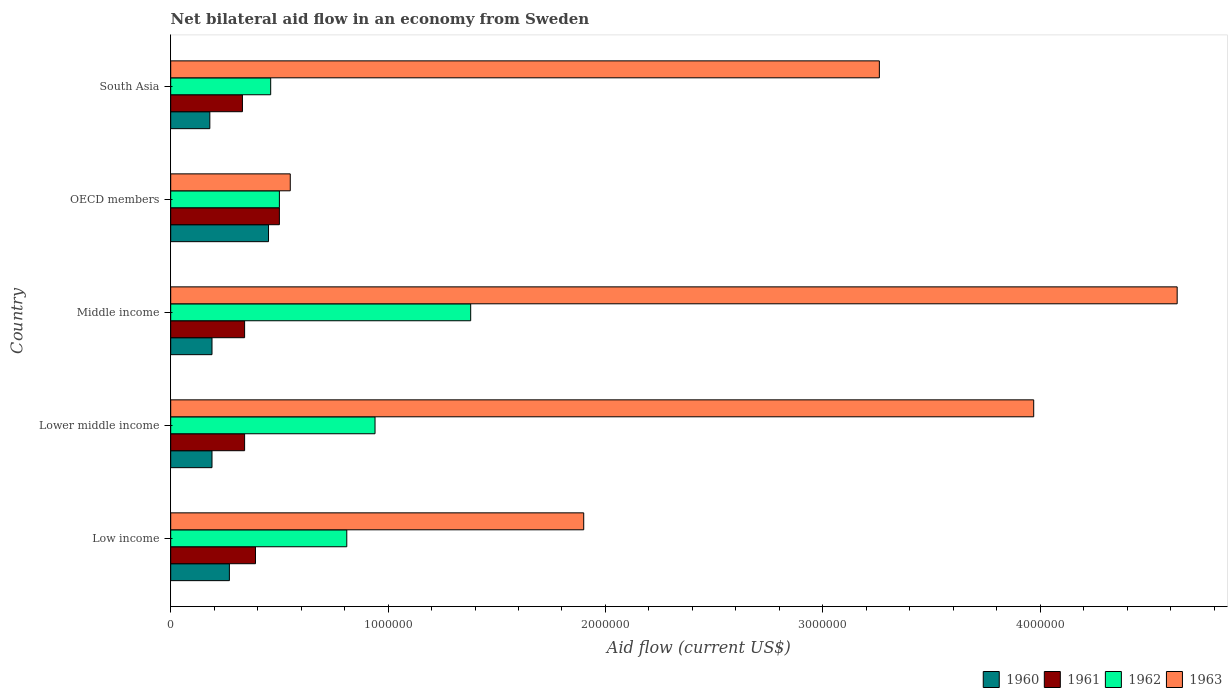How many different coloured bars are there?
Make the answer very short. 4. How many bars are there on the 2nd tick from the top?
Ensure brevity in your answer.  4. What is the label of the 2nd group of bars from the top?
Make the answer very short. OECD members. Across all countries, what is the maximum net bilateral aid flow in 1962?
Your answer should be very brief. 1.38e+06. Across all countries, what is the minimum net bilateral aid flow in 1960?
Give a very brief answer. 1.80e+05. In which country was the net bilateral aid flow in 1963 minimum?
Offer a very short reply. OECD members. What is the total net bilateral aid flow in 1963 in the graph?
Your response must be concise. 1.43e+07. What is the difference between the net bilateral aid flow in 1963 in Low income and that in Lower middle income?
Offer a terse response. -2.07e+06. What is the difference between the net bilateral aid flow in 1961 in OECD members and the net bilateral aid flow in 1962 in Lower middle income?
Your answer should be very brief. -4.40e+05. What is the average net bilateral aid flow in 1963 per country?
Give a very brief answer. 2.86e+06. What is the difference between the net bilateral aid flow in 1960 and net bilateral aid flow in 1963 in South Asia?
Your answer should be compact. -3.08e+06. What is the ratio of the net bilateral aid flow in 1962 in Lower middle income to that in Middle income?
Offer a very short reply. 0.68. Is the net bilateral aid flow in 1963 in Middle income less than that in South Asia?
Ensure brevity in your answer.  No. What is the difference between the highest and the second highest net bilateral aid flow in 1961?
Give a very brief answer. 1.10e+05. What is the difference between the highest and the lowest net bilateral aid flow in 1962?
Your response must be concise. 9.20e+05. Is it the case that in every country, the sum of the net bilateral aid flow in 1961 and net bilateral aid flow in 1962 is greater than the sum of net bilateral aid flow in 1963 and net bilateral aid flow in 1960?
Offer a terse response. No. What does the 4th bar from the top in OECD members represents?
Provide a short and direct response. 1960. Is it the case that in every country, the sum of the net bilateral aid flow in 1962 and net bilateral aid flow in 1960 is greater than the net bilateral aid flow in 1963?
Your answer should be very brief. No. How many countries are there in the graph?
Give a very brief answer. 5. Where does the legend appear in the graph?
Make the answer very short. Bottom right. What is the title of the graph?
Give a very brief answer. Net bilateral aid flow in an economy from Sweden. Does "1993" appear as one of the legend labels in the graph?
Your answer should be very brief. No. What is the label or title of the X-axis?
Offer a very short reply. Aid flow (current US$). What is the Aid flow (current US$) in 1960 in Low income?
Provide a short and direct response. 2.70e+05. What is the Aid flow (current US$) in 1962 in Low income?
Keep it short and to the point. 8.10e+05. What is the Aid flow (current US$) of 1963 in Low income?
Keep it short and to the point. 1.90e+06. What is the Aid flow (current US$) of 1961 in Lower middle income?
Your answer should be very brief. 3.40e+05. What is the Aid flow (current US$) in 1962 in Lower middle income?
Make the answer very short. 9.40e+05. What is the Aid flow (current US$) of 1963 in Lower middle income?
Offer a very short reply. 3.97e+06. What is the Aid flow (current US$) in 1960 in Middle income?
Your response must be concise. 1.90e+05. What is the Aid flow (current US$) of 1961 in Middle income?
Ensure brevity in your answer.  3.40e+05. What is the Aid flow (current US$) of 1962 in Middle income?
Make the answer very short. 1.38e+06. What is the Aid flow (current US$) of 1963 in Middle income?
Your response must be concise. 4.63e+06. What is the Aid flow (current US$) of 1960 in OECD members?
Your response must be concise. 4.50e+05. What is the Aid flow (current US$) of 1961 in OECD members?
Offer a very short reply. 5.00e+05. What is the Aid flow (current US$) of 1962 in South Asia?
Your response must be concise. 4.60e+05. What is the Aid flow (current US$) in 1963 in South Asia?
Make the answer very short. 3.26e+06. Across all countries, what is the maximum Aid flow (current US$) in 1961?
Give a very brief answer. 5.00e+05. Across all countries, what is the maximum Aid flow (current US$) of 1962?
Ensure brevity in your answer.  1.38e+06. Across all countries, what is the maximum Aid flow (current US$) in 1963?
Your answer should be very brief. 4.63e+06. Across all countries, what is the minimum Aid flow (current US$) of 1960?
Your response must be concise. 1.80e+05. Across all countries, what is the minimum Aid flow (current US$) in 1962?
Give a very brief answer. 4.60e+05. What is the total Aid flow (current US$) of 1960 in the graph?
Your answer should be very brief. 1.28e+06. What is the total Aid flow (current US$) in 1961 in the graph?
Your answer should be very brief. 1.90e+06. What is the total Aid flow (current US$) of 1962 in the graph?
Make the answer very short. 4.09e+06. What is the total Aid flow (current US$) in 1963 in the graph?
Offer a very short reply. 1.43e+07. What is the difference between the Aid flow (current US$) in 1961 in Low income and that in Lower middle income?
Your answer should be compact. 5.00e+04. What is the difference between the Aid flow (current US$) of 1962 in Low income and that in Lower middle income?
Give a very brief answer. -1.30e+05. What is the difference between the Aid flow (current US$) of 1963 in Low income and that in Lower middle income?
Your answer should be very brief. -2.07e+06. What is the difference between the Aid flow (current US$) of 1962 in Low income and that in Middle income?
Make the answer very short. -5.70e+05. What is the difference between the Aid flow (current US$) in 1963 in Low income and that in Middle income?
Your answer should be compact. -2.73e+06. What is the difference between the Aid flow (current US$) of 1961 in Low income and that in OECD members?
Provide a succinct answer. -1.10e+05. What is the difference between the Aid flow (current US$) in 1962 in Low income and that in OECD members?
Your answer should be compact. 3.10e+05. What is the difference between the Aid flow (current US$) of 1963 in Low income and that in OECD members?
Ensure brevity in your answer.  1.35e+06. What is the difference between the Aid flow (current US$) in 1961 in Low income and that in South Asia?
Keep it short and to the point. 6.00e+04. What is the difference between the Aid flow (current US$) in 1963 in Low income and that in South Asia?
Give a very brief answer. -1.36e+06. What is the difference between the Aid flow (current US$) of 1960 in Lower middle income and that in Middle income?
Offer a very short reply. 0. What is the difference between the Aid flow (current US$) of 1961 in Lower middle income and that in Middle income?
Your answer should be very brief. 0. What is the difference between the Aid flow (current US$) of 1962 in Lower middle income and that in Middle income?
Ensure brevity in your answer.  -4.40e+05. What is the difference between the Aid flow (current US$) of 1963 in Lower middle income and that in Middle income?
Offer a very short reply. -6.60e+05. What is the difference between the Aid flow (current US$) of 1960 in Lower middle income and that in OECD members?
Ensure brevity in your answer.  -2.60e+05. What is the difference between the Aid flow (current US$) of 1961 in Lower middle income and that in OECD members?
Provide a succinct answer. -1.60e+05. What is the difference between the Aid flow (current US$) in 1962 in Lower middle income and that in OECD members?
Offer a very short reply. 4.40e+05. What is the difference between the Aid flow (current US$) of 1963 in Lower middle income and that in OECD members?
Your response must be concise. 3.42e+06. What is the difference between the Aid flow (current US$) in 1961 in Lower middle income and that in South Asia?
Make the answer very short. 10000. What is the difference between the Aid flow (current US$) in 1963 in Lower middle income and that in South Asia?
Your answer should be compact. 7.10e+05. What is the difference between the Aid flow (current US$) in 1961 in Middle income and that in OECD members?
Provide a short and direct response. -1.60e+05. What is the difference between the Aid flow (current US$) of 1962 in Middle income and that in OECD members?
Make the answer very short. 8.80e+05. What is the difference between the Aid flow (current US$) in 1963 in Middle income and that in OECD members?
Provide a short and direct response. 4.08e+06. What is the difference between the Aid flow (current US$) in 1962 in Middle income and that in South Asia?
Your response must be concise. 9.20e+05. What is the difference between the Aid flow (current US$) of 1963 in Middle income and that in South Asia?
Your answer should be compact. 1.37e+06. What is the difference between the Aid flow (current US$) in 1963 in OECD members and that in South Asia?
Give a very brief answer. -2.71e+06. What is the difference between the Aid flow (current US$) of 1960 in Low income and the Aid flow (current US$) of 1962 in Lower middle income?
Your response must be concise. -6.70e+05. What is the difference between the Aid flow (current US$) of 1960 in Low income and the Aid flow (current US$) of 1963 in Lower middle income?
Offer a terse response. -3.70e+06. What is the difference between the Aid flow (current US$) of 1961 in Low income and the Aid flow (current US$) of 1962 in Lower middle income?
Your answer should be compact. -5.50e+05. What is the difference between the Aid flow (current US$) of 1961 in Low income and the Aid flow (current US$) of 1963 in Lower middle income?
Your response must be concise. -3.58e+06. What is the difference between the Aid flow (current US$) in 1962 in Low income and the Aid flow (current US$) in 1963 in Lower middle income?
Keep it short and to the point. -3.16e+06. What is the difference between the Aid flow (current US$) in 1960 in Low income and the Aid flow (current US$) in 1962 in Middle income?
Make the answer very short. -1.11e+06. What is the difference between the Aid flow (current US$) of 1960 in Low income and the Aid flow (current US$) of 1963 in Middle income?
Keep it short and to the point. -4.36e+06. What is the difference between the Aid flow (current US$) of 1961 in Low income and the Aid flow (current US$) of 1962 in Middle income?
Give a very brief answer. -9.90e+05. What is the difference between the Aid flow (current US$) of 1961 in Low income and the Aid flow (current US$) of 1963 in Middle income?
Keep it short and to the point. -4.24e+06. What is the difference between the Aid flow (current US$) of 1962 in Low income and the Aid flow (current US$) of 1963 in Middle income?
Your answer should be compact. -3.82e+06. What is the difference between the Aid flow (current US$) of 1960 in Low income and the Aid flow (current US$) of 1963 in OECD members?
Your answer should be compact. -2.80e+05. What is the difference between the Aid flow (current US$) in 1961 in Low income and the Aid flow (current US$) in 1962 in OECD members?
Your answer should be compact. -1.10e+05. What is the difference between the Aid flow (current US$) in 1960 in Low income and the Aid flow (current US$) in 1961 in South Asia?
Your answer should be compact. -6.00e+04. What is the difference between the Aid flow (current US$) in 1960 in Low income and the Aid flow (current US$) in 1963 in South Asia?
Your answer should be very brief. -2.99e+06. What is the difference between the Aid flow (current US$) in 1961 in Low income and the Aid flow (current US$) in 1962 in South Asia?
Provide a succinct answer. -7.00e+04. What is the difference between the Aid flow (current US$) of 1961 in Low income and the Aid flow (current US$) of 1963 in South Asia?
Give a very brief answer. -2.87e+06. What is the difference between the Aid flow (current US$) of 1962 in Low income and the Aid flow (current US$) of 1963 in South Asia?
Offer a terse response. -2.45e+06. What is the difference between the Aid flow (current US$) of 1960 in Lower middle income and the Aid flow (current US$) of 1961 in Middle income?
Offer a terse response. -1.50e+05. What is the difference between the Aid flow (current US$) in 1960 in Lower middle income and the Aid flow (current US$) in 1962 in Middle income?
Ensure brevity in your answer.  -1.19e+06. What is the difference between the Aid flow (current US$) in 1960 in Lower middle income and the Aid flow (current US$) in 1963 in Middle income?
Keep it short and to the point. -4.44e+06. What is the difference between the Aid flow (current US$) in 1961 in Lower middle income and the Aid flow (current US$) in 1962 in Middle income?
Offer a terse response. -1.04e+06. What is the difference between the Aid flow (current US$) in 1961 in Lower middle income and the Aid flow (current US$) in 1963 in Middle income?
Offer a very short reply. -4.29e+06. What is the difference between the Aid flow (current US$) in 1962 in Lower middle income and the Aid flow (current US$) in 1963 in Middle income?
Your answer should be very brief. -3.69e+06. What is the difference between the Aid flow (current US$) of 1960 in Lower middle income and the Aid flow (current US$) of 1961 in OECD members?
Provide a short and direct response. -3.10e+05. What is the difference between the Aid flow (current US$) of 1960 in Lower middle income and the Aid flow (current US$) of 1962 in OECD members?
Keep it short and to the point. -3.10e+05. What is the difference between the Aid flow (current US$) in 1960 in Lower middle income and the Aid flow (current US$) in 1963 in OECD members?
Make the answer very short. -3.60e+05. What is the difference between the Aid flow (current US$) in 1962 in Lower middle income and the Aid flow (current US$) in 1963 in OECD members?
Give a very brief answer. 3.90e+05. What is the difference between the Aid flow (current US$) in 1960 in Lower middle income and the Aid flow (current US$) in 1962 in South Asia?
Your answer should be very brief. -2.70e+05. What is the difference between the Aid flow (current US$) in 1960 in Lower middle income and the Aid flow (current US$) in 1963 in South Asia?
Keep it short and to the point. -3.07e+06. What is the difference between the Aid flow (current US$) in 1961 in Lower middle income and the Aid flow (current US$) in 1963 in South Asia?
Keep it short and to the point. -2.92e+06. What is the difference between the Aid flow (current US$) of 1962 in Lower middle income and the Aid flow (current US$) of 1963 in South Asia?
Your answer should be very brief. -2.32e+06. What is the difference between the Aid flow (current US$) in 1960 in Middle income and the Aid flow (current US$) in 1961 in OECD members?
Offer a very short reply. -3.10e+05. What is the difference between the Aid flow (current US$) in 1960 in Middle income and the Aid flow (current US$) in 1962 in OECD members?
Ensure brevity in your answer.  -3.10e+05. What is the difference between the Aid flow (current US$) of 1960 in Middle income and the Aid flow (current US$) of 1963 in OECD members?
Keep it short and to the point. -3.60e+05. What is the difference between the Aid flow (current US$) in 1962 in Middle income and the Aid flow (current US$) in 1963 in OECD members?
Keep it short and to the point. 8.30e+05. What is the difference between the Aid flow (current US$) of 1960 in Middle income and the Aid flow (current US$) of 1963 in South Asia?
Offer a terse response. -3.07e+06. What is the difference between the Aid flow (current US$) in 1961 in Middle income and the Aid flow (current US$) in 1962 in South Asia?
Your answer should be very brief. -1.20e+05. What is the difference between the Aid flow (current US$) of 1961 in Middle income and the Aid flow (current US$) of 1963 in South Asia?
Ensure brevity in your answer.  -2.92e+06. What is the difference between the Aid flow (current US$) in 1962 in Middle income and the Aid flow (current US$) in 1963 in South Asia?
Make the answer very short. -1.88e+06. What is the difference between the Aid flow (current US$) in 1960 in OECD members and the Aid flow (current US$) in 1961 in South Asia?
Provide a succinct answer. 1.20e+05. What is the difference between the Aid flow (current US$) in 1960 in OECD members and the Aid flow (current US$) in 1963 in South Asia?
Your answer should be compact. -2.81e+06. What is the difference between the Aid flow (current US$) of 1961 in OECD members and the Aid flow (current US$) of 1962 in South Asia?
Your answer should be very brief. 4.00e+04. What is the difference between the Aid flow (current US$) in 1961 in OECD members and the Aid flow (current US$) in 1963 in South Asia?
Offer a terse response. -2.76e+06. What is the difference between the Aid flow (current US$) of 1962 in OECD members and the Aid flow (current US$) of 1963 in South Asia?
Ensure brevity in your answer.  -2.76e+06. What is the average Aid flow (current US$) in 1960 per country?
Your answer should be very brief. 2.56e+05. What is the average Aid flow (current US$) of 1962 per country?
Ensure brevity in your answer.  8.18e+05. What is the average Aid flow (current US$) in 1963 per country?
Your answer should be compact. 2.86e+06. What is the difference between the Aid flow (current US$) of 1960 and Aid flow (current US$) of 1962 in Low income?
Keep it short and to the point. -5.40e+05. What is the difference between the Aid flow (current US$) of 1960 and Aid flow (current US$) of 1963 in Low income?
Provide a succinct answer. -1.63e+06. What is the difference between the Aid flow (current US$) in 1961 and Aid flow (current US$) in 1962 in Low income?
Make the answer very short. -4.20e+05. What is the difference between the Aid flow (current US$) in 1961 and Aid flow (current US$) in 1963 in Low income?
Make the answer very short. -1.51e+06. What is the difference between the Aid flow (current US$) of 1962 and Aid flow (current US$) of 1963 in Low income?
Keep it short and to the point. -1.09e+06. What is the difference between the Aid flow (current US$) in 1960 and Aid flow (current US$) in 1962 in Lower middle income?
Make the answer very short. -7.50e+05. What is the difference between the Aid flow (current US$) of 1960 and Aid flow (current US$) of 1963 in Lower middle income?
Make the answer very short. -3.78e+06. What is the difference between the Aid flow (current US$) in 1961 and Aid flow (current US$) in 1962 in Lower middle income?
Make the answer very short. -6.00e+05. What is the difference between the Aid flow (current US$) of 1961 and Aid flow (current US$) of 1963 in Lower middle income?
Your answer should be very brief. -3.63e+06. What is the difference between the Aid flow (current US$) in 1962 and Aid flow (current US$) in 1963 in Lower middle income?
Your answer should be very brief. -3.03e+06. What is the difference between the Aid flow (current US$) of 1960 and Aid flow (current US$) of 1962 in Middle income?
Your response must be concise. -1.19e+06. What is the difference between the Aid flow (current US$) of 1960 and Aid flow (current US$) of 1963 in Middle income?
Keep it short and to the point. -4.44e+06. What is the difference between the Aid flow (current US$) of 1961 and Aid flow (current US$) of 1962 in Middle income?
Keep it short and to the point. -1.04e+06. What is the difference between the Aid flow (current US$) in 1961 and Aid flow (current US$) in 1963 in Middle income?
Keep it short and to the point. -4.29e+06. What is the difference between the Aid flow (current US$) of 1962 and Aid flow (current US$) of 1963 in Middle income?
Keep it short and to the point. -3.25e+06. What is the difference between the Aid flow (current US$) in 1960 and Aid flow (current US$) in 1961 in OECD members?
Offer a terse response. -5.00e+04. What is the difference between the Aid flow (current US$) in 1960 and Aid flow (current US$) in 1963 in OECD members?
Offer a very short reply. -1.00e+05. What is the difference between the Aid flow (current US$) in 1960 and Aid flow (current US$) in 1962 in South Asia?
Your answer should be very brief. -2.80e+05. What is the difference between the Aid flow (current US$) in 1960 and Aid flow (current US$) in 1963 in South Asia?
Make the answer very short. -3.08e+06. What is the difference between the Aid flow (current US$) in 1961 and Aid flow (current US$) in 1962 in South Asia?
Offer a terse response. -1.30e+05. What is the difference between the Aid flow (current US$) in 1961 and Aid flow (current US$) in 1963 in South Asia?
Your response must be concise. -2.93e+06. What is the difference between the Aid flow (current US$) of 1962 and Aid flow (current US$) of 1963 in South Asia?
Provide a succinct answer. -2.80e+06. What is the ratio of the Aid flow (current US$) of 1960 in Low income to that in Lower middle income?
Your answer should be very brief. 1.42. What is the ratio of the Aid flow (current US$) of 1961 in Low income to that in Lower middle income?
Offer a very short reply. 1.15. What is the ratio of the Aid flow (current US$) of 1962 in Low income to that in Lower middle income?
Make the answer very short. 0.86. What is the ratio of the Aid flow (current US$) in 1963 in Low income to that in Lower middle income?
Your answer should be very brief. 0.48. What is the ratio of the Aid flow (current US$) of 1960 in Low income to that in Middle income?
Keep it short and to the point. 1.42. What is the ratio of the Aid flow (current US$) of 1961 in Low income to that in Middle income?
Offer a very short reply. 1.15. What is the ratio of the Aid flow (current US$) of 1962 in Low income to that in Middle income?
Provide a short and direct response. 0.59. What is the ratio of the Aid flow (current US$) in 1963 in Low income to that in Middle income?
Offer a very short reply. 0.41. What is the ratio of the Aid flow (current US$) in 1960 in Low income to that in OECD members?
Make the answer very short. 0.6. What is the ratio of the Aid flow (current US$) of 1961 in Low income to that in OECD members?
Provide a succinct answer. 0.78. What is the ratio of the Aid flow (current US$) of 1962 in Low income to that in OECD members?
Your answer should be compact. 1.62. What is the ratio of the Aid flow (current US$) of 1963 in Low income to that in OECD members?
Provide a succinct answer. 3.45. What is the ratio of the Aid flow (current US$) of 1961 in Low income to that in South Asia?
Offer a terse response. 1.18. What is the ratio of the Aid flow (current US$) of 1962 in Low income to that in South Asia?
Your answer should be very brief. 1.76. What is the ratio of the Aid flow (current US$) of 1963 in Low income to that in South Asia?
Your response must be concise. 0.58. What is the ratio of the Aid flow (current US$) of 1960 in Lower middle income to that in Middle income?
Offer a terse response. 1. What is the ratio of the Aid flow (current US$) in 1961 in Lower middle income to that in Middle income?
Your answer should be very brief. 1. What is the ratio of the Aid flow (current US$) in 1962 in Lower middle income to that in Middle income?
Provide a short and direct response. 0.68. What is the ratio of the Aid flow (current US$) of 1963 in Lower middle income to that in Middle income?
Offer a very short reply. 0.86. What is the ratio of the Aid flow (current US$) in 1960 in Lower middle income to that in OECD members?
Offer a terse response. 0.42. What is the ratio of the Aid flow (current US$) of 1961 in Lower middle income to that in OECD members?
Your answer should be very brief. 0.68. What is the ratio of the Aid flow (current US$) in 1962 in Lower middle income to that in OECD members?
Your response must be concise. 1.88. What is the ratio of the Aid flow (current US$) of 1963 in Lower middle income to that in OECD members?
Offer a terse response. 7.22. What is the ratio of the Aid flow (current US$) of 1960 in Lower middle income to that in South Asia?
Your response must be concise. 1.06. What is the ratio of the Aid flow (current US$) in 1961 in Lower middle income to that in South Asia?
Provide a succinct answer. 1.03. What is the ratio of the Aid flow (current US$) in 1962 in Lower middle income to that in South Asia?
Keep it short and to the point. 2.04. What is the ratio of the Aid flow (current US$) of 1963 in Lower middle income to that in South Asia?
Offer a terse response. 1.22. What is the ratio of the Aid flow (current US$) of 1960 in Middle income to that in OECD members?
Give a very brief answer. 0.42. What is the ratio of the Aid flow (current US$) of 1961 in Middle income to that in OECD members?
Make the answer very short. 0.68. What is the ratio of the Aid flow (current US$) of 1962 in Middle income to that in OECD members?
Give a very brief answer. 2.76. What is the ratio of the Aid flow (current US$) of 1963 in Middle income to that in OECD members?
Your response must be concise. 8.42. What is the ratio of the Aid flow (current US$) in 1960 in Middle income to that in South Asia?
Provide a short and direct response. 1.06. What is the ratio of the Aid flow (current US$) of 1961 in Middle income to that in South Asia?
Your response must be concise. 1.03. What is the ratio of the Aid flow (current US$) in 1962 in Middle income to that in South Asia?
Offer a terse response. 3. What is the ratio of the Aid flow (current US$) of 1963 in Middle income to that in South Asia?
Offer a very short reply. 1.42. What is the ratio of the Aid flow (current US$) in 1961 in OECD members to that in South Asia?
Make the answer very short. 1.52. What is the ratio of the Aid flow (current US$) of 1962 in OECD members to that in South Asia?
Provide a succinct answer. 1.09. What is the ratio of the Aid flow (current US$) in 1963 in OECD members to that in South Asia?
Your response must be concise. 0.17. What is the difference between the highest and the second highest Aid flow (current US$) in 1960?
Offer a very short reply. 1.80e+05. What is the difference between the highest and the second highest Aid flow (current US$) of 1961?
Give a very brief answer. 1.10e+05. What is the difference between the highest and the lowest Aid flow (current US$) of 1960?
Provide a short and direct response. 2.70e+05. What is the difference between the highest and the lowest Aid flow (current US$) of 1961?
Ensure brevity in your answer.  1.70e+05. What is the difference between the highest and the lowest Aid flow (current US$) in 1962?
Provide a short and direct response. 9.20e+05. What is the difference between the highest and the lowest Aid flow (current US$) in 1963?
Provide a succinct answer. 4.08e+06. 